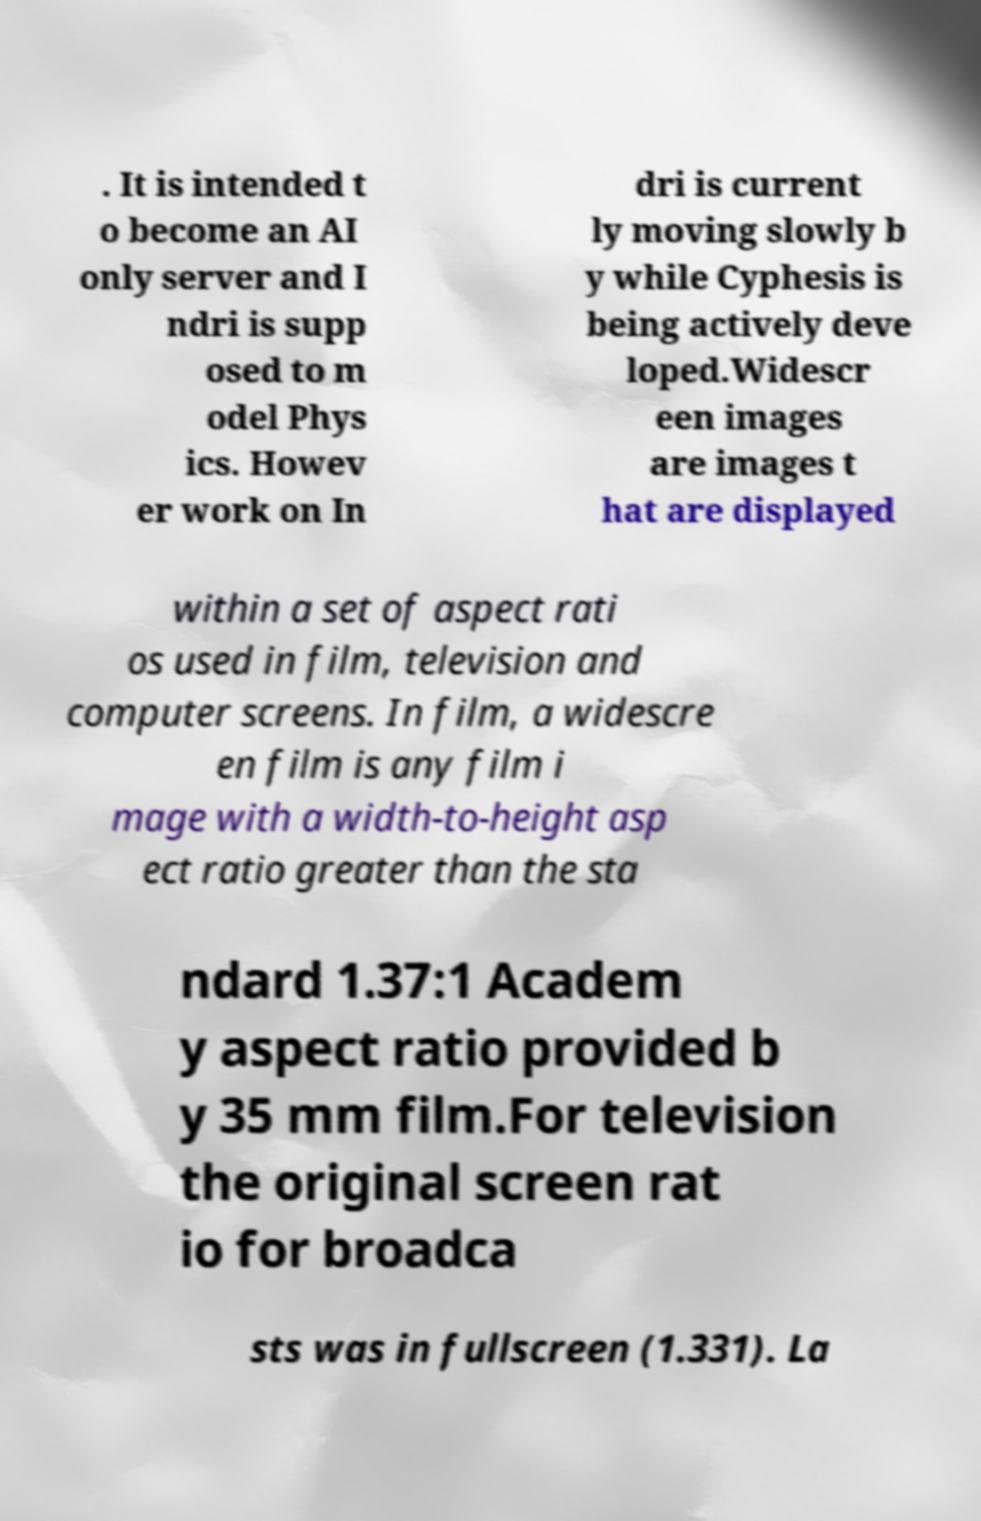Can you read and provide the text displayed in the image?This photo seems to have some interesting text. Can you extract and type it out for me? . It is intended t o become an AI only server and I ndri is supp osed to m odel Phys ics. Howev er work on In dri is current ly moving slowly b y while Cyphesis is being actively deve loped.Widescr een images are images t hat are displayed within a set of aspect rati os used in film, television and computer screens. In film, a widescre en film is any film i mage with a width-to-height asp ect ratio greater than the sta ndard 1.37:1 Academ y aspect ratio provided b y 35 mm film.For television the original screen rat io for broadca sts was in fullscreen (1.331). La 